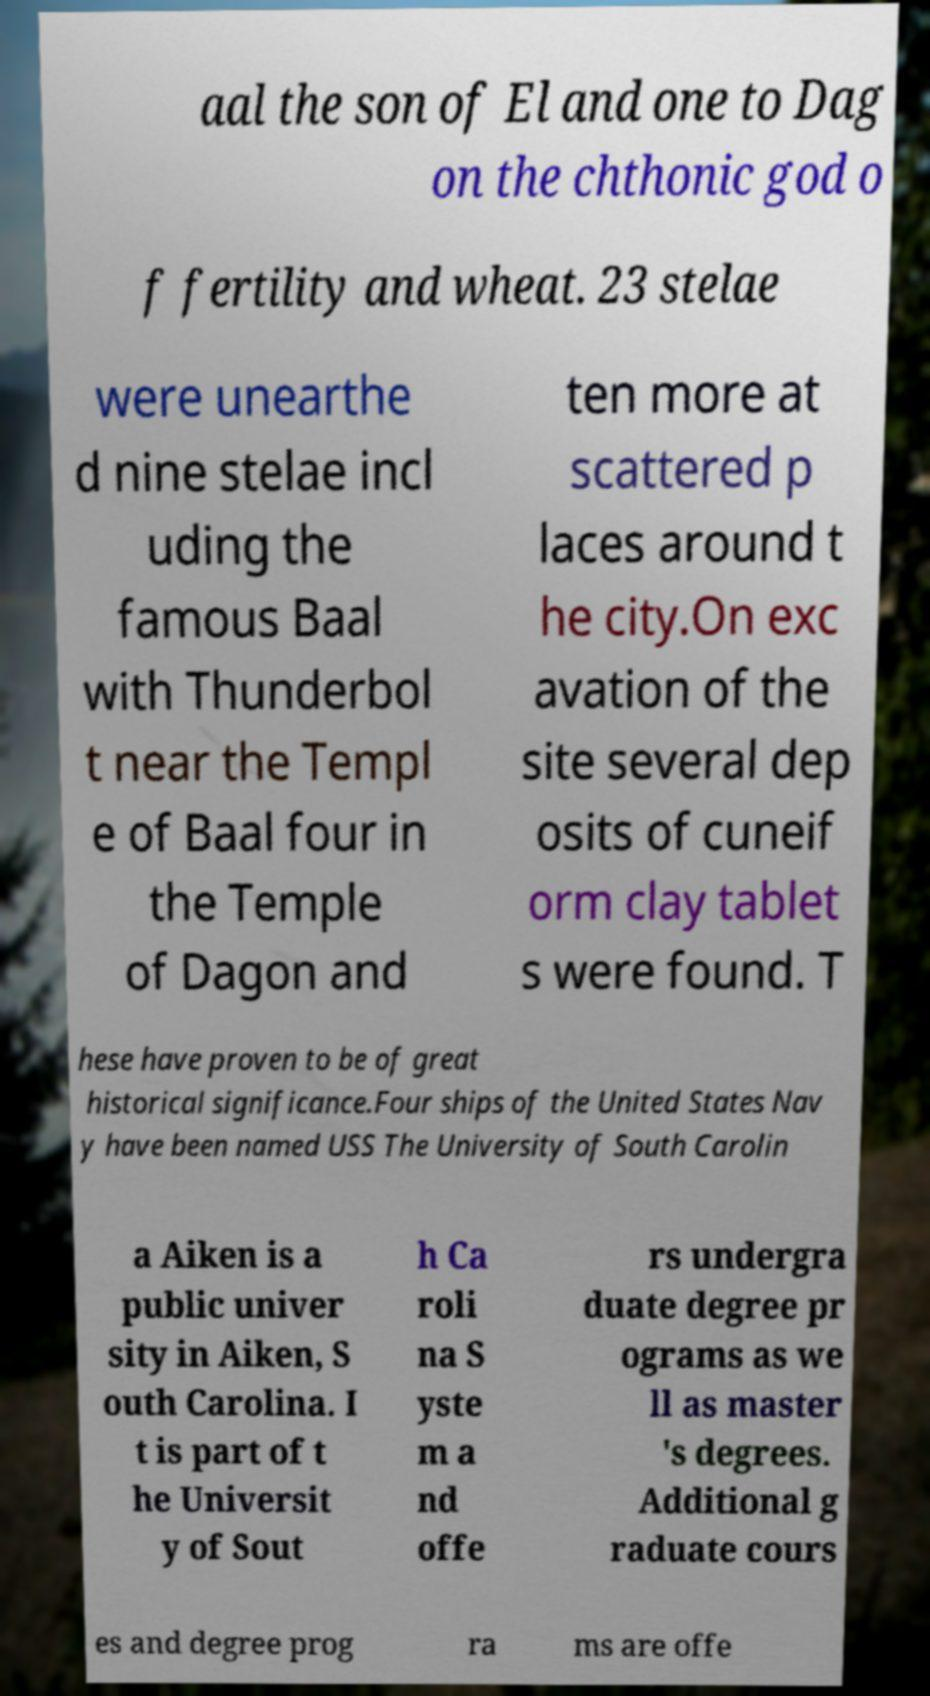What messages or text are displayed in this image? I need them in a readable, typed format. aal the son of El and one to Dag on the chthonic god o f fertility and wheat. 23 stelae were unearthe d nine stelae incl uding the famous Baal with Thunderbol t near the Templ e of Baal four in the Temple of Dagon and ten more at scattered p laces around t he city.On exc avation of the site several dep osits of cuneif orm clay tablet s were found. T hese have proven to be of great historical significance.Four ships of the United States Nav y have been named USS The University of South Carolin a Aiken is a public univer sity in Aiken, S outh Carolina. I t is part of t he Universit y of Sout h Ca roli na S yste m a nd offe rs undergra duate degree pr ograms as we ll as master 's degrees. Additional g raduate cours es and degree prog ra ms are offe 